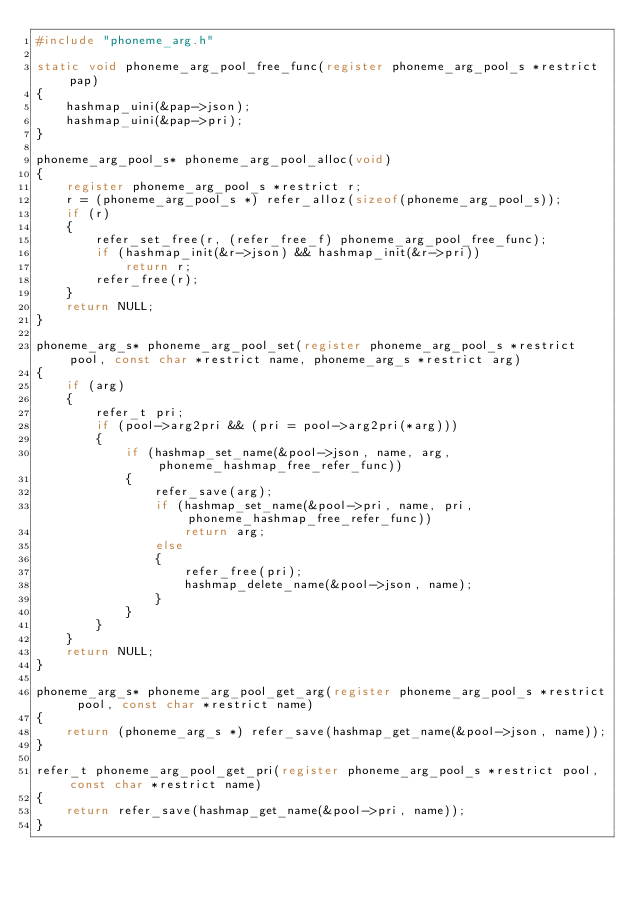<code> <loc_0><loc_0><loc_500><loc_500><_C_>#include "phoneme_arg.h"

static void phoneme_arg_pool_free_func(register phoneme_arg_pool_s *restrict pap)
{
	hashmap_uini(&pap->json);
	hashmap_uini(&pap->pri);
}

phoneme_arg_pool_s* phoneme_arg_pool_alloc(void)
{
	register phoneme_arg_pool_s *restrict r;
	r = (phoneme_arg_pool_s *) refer_alloz(sizeof(phoneme_arg_pool_s));
	if (r)
	{
		refer_set_free(r, (refer_free_f) phoneme_arg_pool_free_func);
		if (hashmap_init(&r->json) && hashmap_init(&r->pri))
			return r;
		refer_free(r);
	}
	return NULL;
}

phoneme_arg_s* phoneme_arg_pool_set(register phoneme_arg_pool_s *restrict pool, const char *restrict name, phoneme_arg_s *restrict arg)
{
	if (arg)
	{
		refer_t pri;
		if (pool->arg2pri && (pri = pool->arg2pri(*arg)))
		{
			if (hashmap_set_name(&pool->json, name, arg, phoneme_hashmap_free_refer_func))
			{
				refer_save(arg);
				if (hashmap_set_name(&pool->pri, name, pri, phoneme_hashmap_free_refer_func))
					return arg;
				else
				{
					refer_free(pri);
					hashmap_delete_name(&pool->json, name);
				}
			}
		}
	}
	return NULL;
}

phoneme_arg_s* phoneme_arg_pool_get_arg(register phoneme_arg_pool_s *restrict pool, const char *restrict name)
{
	return (phoneme_arg_s *) refer_save(hashmap_get_name(&pool->json, name));
}

refer_t phoneme_arg_pool_get_pri(register phoneme_arg_pool_s *restrict pool, const char *restrict name)
{
	return refer_save(hashmap_get_name(&pool->pri, name));
}
</code> 